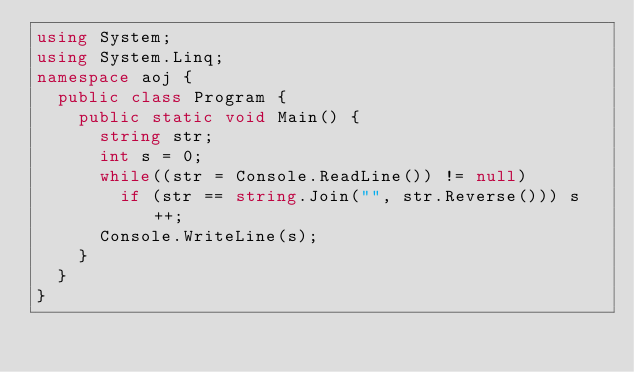<code> <loc_0><loc_0><loc_500><loc_500><_C#_>using System;
using System.Linq;
namespace aoj {
	public class Program {
		public static void Main() {
			string str;
			int s = 0;
			while((str = Console.ReadLine()) != null)
				if (str == string.Join("", str.Reverse())) s++;
			Console.WriteLine(s);
		}
	}
}</code> 